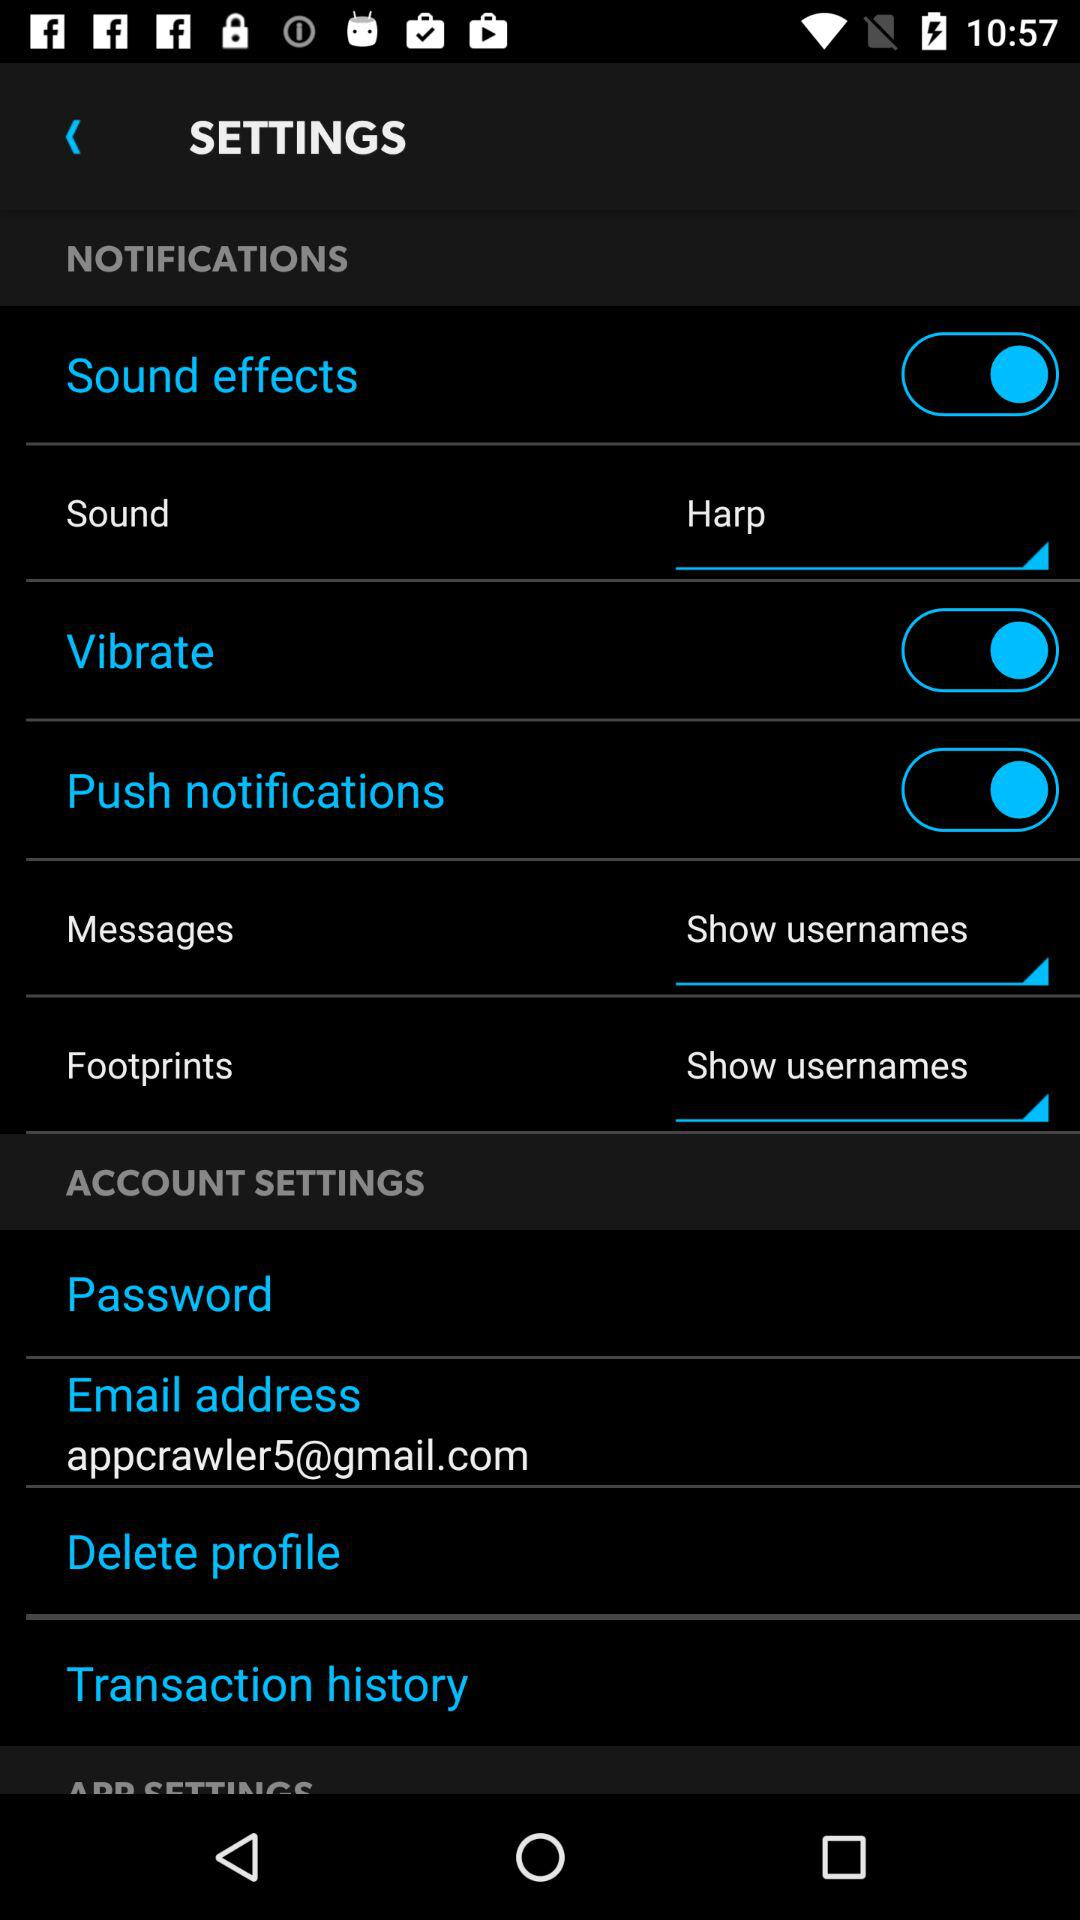What is the email address? The email address is appcrawler5@gmail.com. 